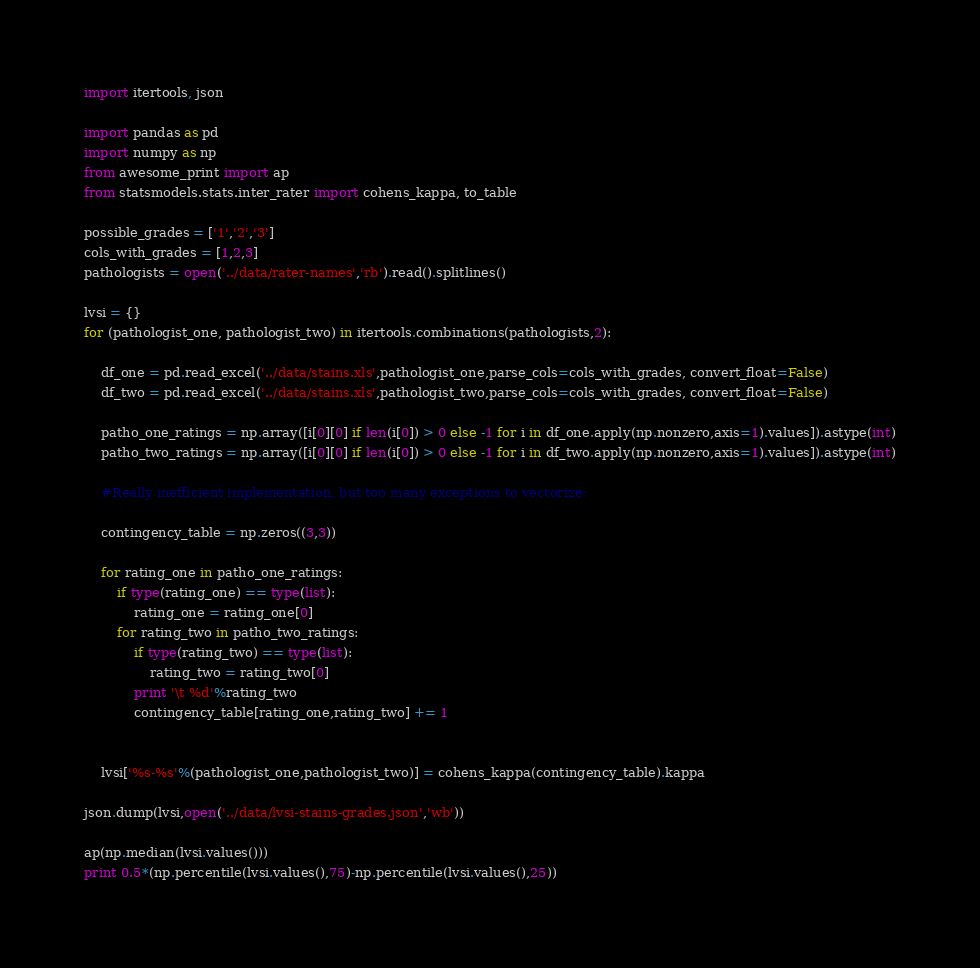<code> <loc_0><loc_0><loc_500><loc_500><_Python_>import itertools, json

import pandas as pd
import numpy as np 
from awesome_print import ap 
from statsmodels.stats.inter_rater import cohens_kappa, to_table

possible_grades = ['1','2','3']
cols_with_grades = [1,2,3]
pathologists = open('../data/rater-names','rb').read().splitlines()

lvsi = {}
for (pathologist_one, pathologist_two) in itertools.combinations(pathologists,2):

	df_one = pd.read_excel('../data/stains.xls',pathologist_one,parse_cols=cols_with_grades, convert_float=False)
	df_two = pd.read_excel('../data/stains.xls',pathologist_two,parse_cols=cols_with_grades, convert_float=False)

	patho_one_ratings = np.array([i[0][0] if len(i[0]) > 0 else -1 for i in df_one.apply(np.nonzero,axis=1).values]).astype(int)
	patho_two_ratings = np.array([i[0][0] if len(i[0]) > 0 else -1 for i in df_two.apply(np.nonzero,axis=1).values]).astype(int)

	#Really inefficient implementation, but too many exceptions to vectorize:

	contingency_table = np.zeros((3,3))

	for rating_one in patho_one_ratings:
		if type(rating_one) == type(list):
			rating_one = rating_one[0]
		for rating_two in patho_two_ratings:
			if type(rating_two) == type(list):
				rating_two = rating_two[0]
			print '\t %d'%rating_two
			contingency_table[rating_one,rating_two] += 1


	lvsi['%s-%s'%(pathologist_one,pathologist_two)] = cohens_kappa(contingency_table).kappa

json.dump(lvsi,open('../data/lvsi-stains-grades.json','wb'))

ap(np.median(lvsi.values()))
print 0.5*(np.percentile(lvsi.values(),75)-np.percentile(lvsi.values(),25))</code> 